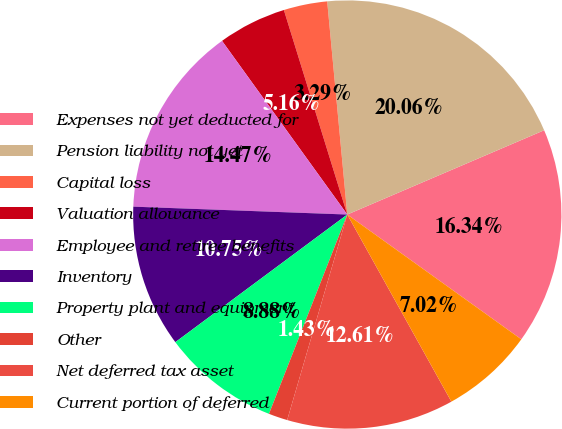Convert chart to OTSL. <chart><loc_0><loc_0><loc_500><loc_500><pie_chart><fcel>Expenses not yet deducted for<fcel>Pension liability not yet<fcel>Capital loss<fcel>Valuation allowance<fcel>Employee and retiree benefits<fcel>Inventory<fcel>Property plant and equipment<fcel>Other<fcel>Net deferred tax asset<fcel>Current portion of deferred<nl><fcel>16.34%<fcel>20.06%<fcel>3.29%<fcel>5.16%<fcel>14.47%<fcel>10.75%<fcel>8.88%<fcel>1.43%<fcel>12.61%<fcel>7.02%<nl></chart> 